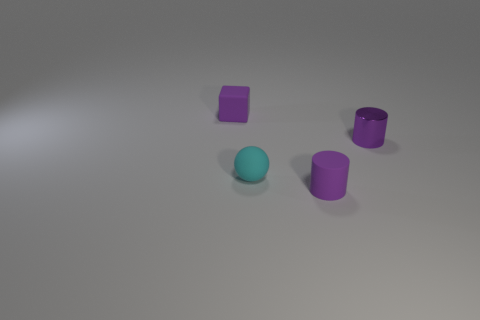What color is the cylinder that is on the right side of the tiny purple cylinder that is left of the cylinder behind the cyan sphere?
Your answer should be very brief. Purple. What material is the other purple thing that is the same shape as the purple shiny object?
Provide a succinct answer. Rubber. How many cyan rubber balls are the same size as the metal cylinder?
Ensure brevity in your answer.  1. How many tiny cyan rubber balls are there?
Your answer should be very brief. 1. Are the tiny cube and the cylinder right of the small purple matte cylinder made of the same material?
Provide a succinct answer. No. What number of cyan things are tiny rubber spheres or big rubber cylinders?
Your response must be concise. 1. What is the size of the purple cylinder that is made of the same material as the small purple block?
Make the answer very short. Small. How many tiny purple things are the same shape as the cyan rubber object?
Provide a short and direct response. 0. Are there more tiny objects in front of the matte sphere than matte objects right of the tiny purple rubber cylinder?
Provide a succinct answer. Yes. Does the small cube have the same color as the matte object that is on the right side of the tiny cyan object?
Keep it short and to the point. Yes. 